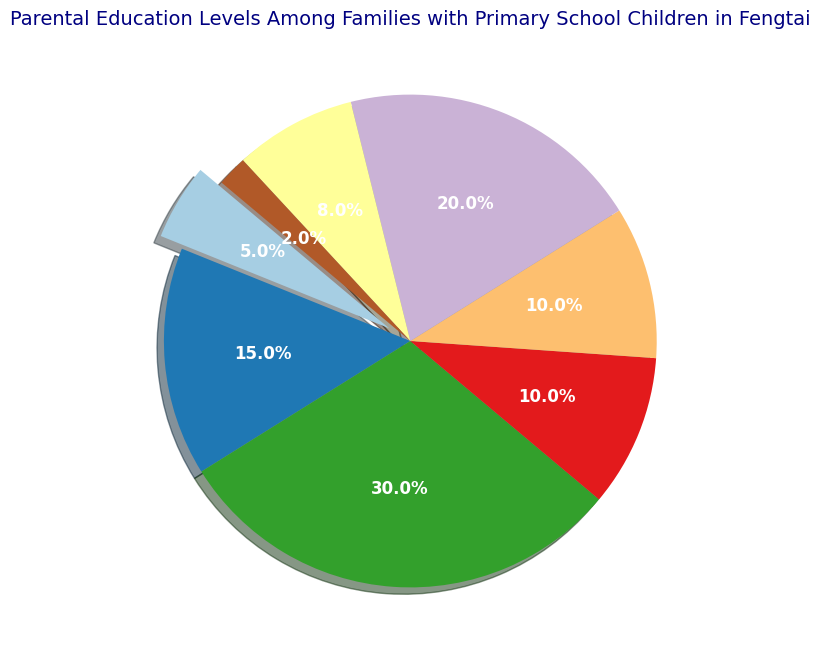what percentage of parents have at least a Bachelor's degree? Add the percentages of those with a Bachelor's Degree, Master's Degree, and Doctorate: 20% + 8% + 2% = 30%
Answer: 30% which education level has the second highest percentage? The education levels and their respective percentages are (Primary School: 5%, Middle School: 15%, High School: 30%, Vocational Training: 10%, Associate Degree: 10%, Bachelor's Degree: 20%, Master's Degree: 8%, Doctorate: 2%). The second highest percentage is Bachelor's Degree with 20%.
Answer: Bachelor's Degree what is the difference in percentage between parents with a Master's Degree and those with a Middle School education? Subtract the percentage of parents with a Master's Degree from those with a Middle School education: 15% - 8% = 7%
Answer: 7% what percentage of parents have an education level less than an Associate Degree? Add the percentages of those with Primary School, Middle School, High School, and Vocational Training: 5% + 15% + 30% + 10% = 60%
Answer: 60% how many education levels have a representation of 10% or more? The education levels with 10% or more are (Middle School: 15%, High School: 30%, Vocational Training: 10%, Associate Degree: 10%, Bachelor's Degree: 20%). There are 5 such levels.
Answer: 5 what percentages are represented by cool colors (blue, green)? There are no specific colors like blue or green mentioned in the description of the pie chart. The chart uses the 'Paired' colormap, which includes various colors. Hence, the cool colors cannot be distinctly identified for specific data points.
Answer: Not applicable 